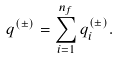<formula> <loc_0><loc_0><loc_500><loc_500>q ^ { ( \pm ) } = \sum _ { i = 1 } ^ { n _ { f } } q _ { i } ^ { ( \pm ) } .</formula> 